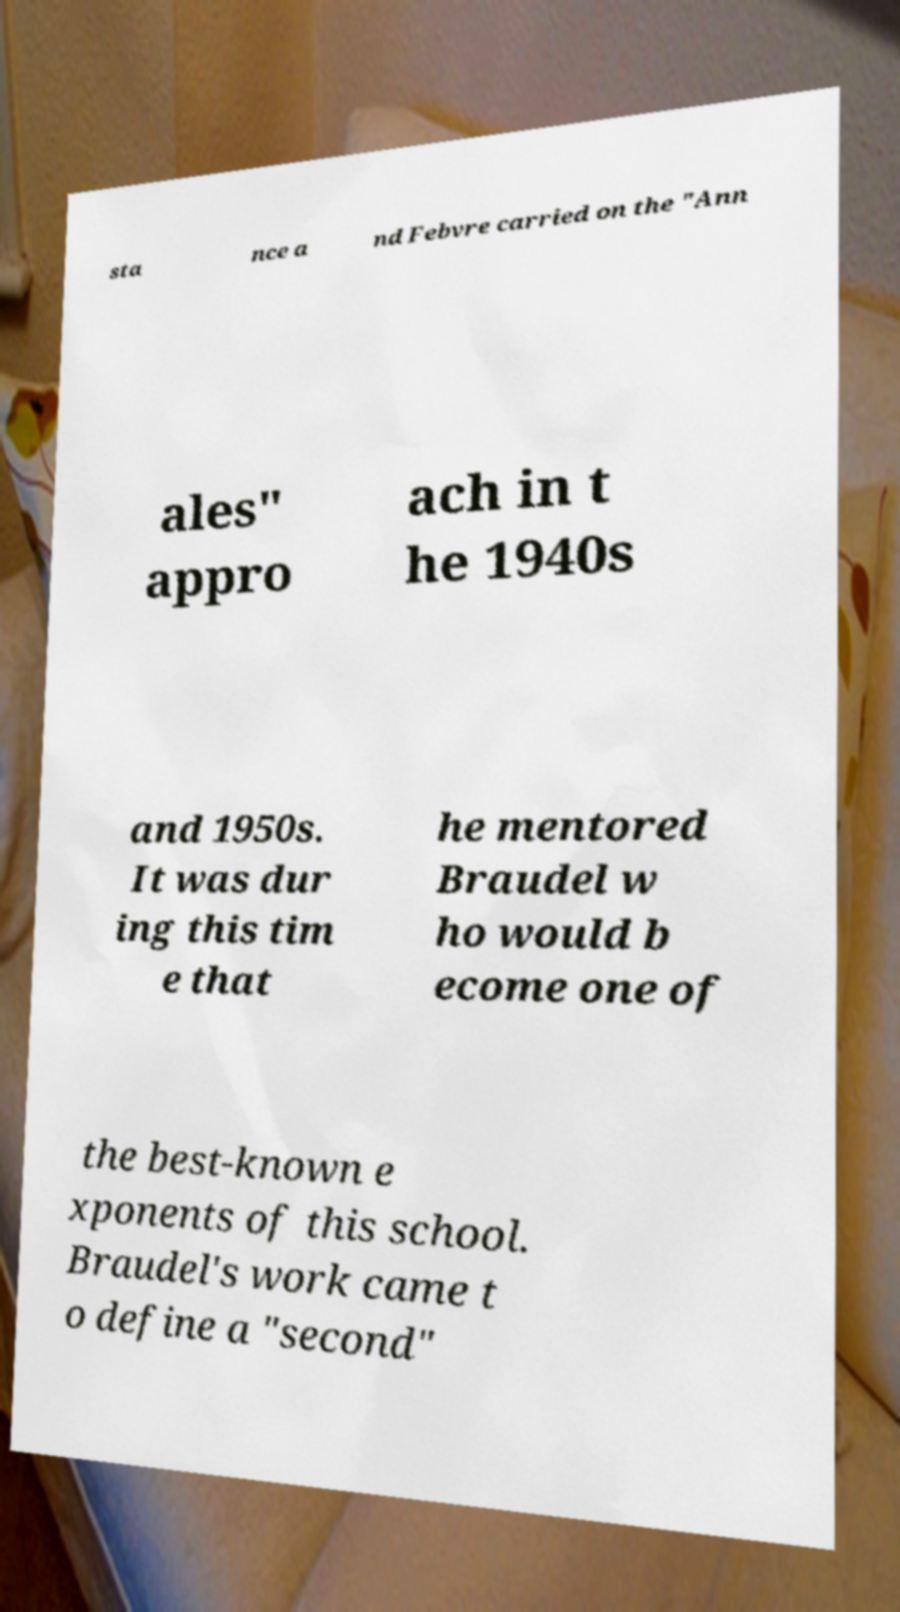Please read and relay the text visible in this image. What does it say? sta nce a nd Febvre carried on the "Ann ales" appro ach in t he 1940s and 1950s. It was dur ing this tim e that he mentored Braudel w ho would b ecome one of the best-known e xponents of this school. Braudel's work came t o define a "second" 